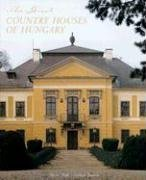Is this book related to Politics & Social Sciences? No, this book is not predominantly related to Politics & Social Sciences. It focuses instead on the architectural grandeur and historical significance of Hungary's country houses, which is distinct from the socio-political narrative. 